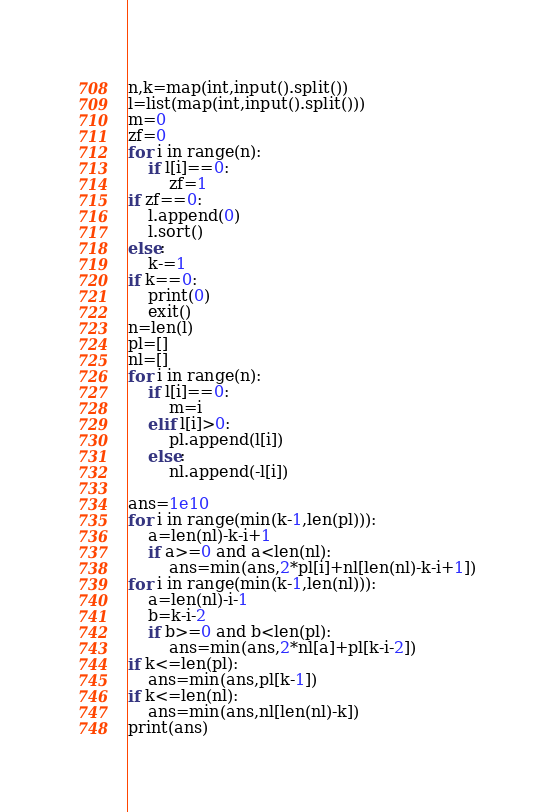<code> <loc_0><loc_0><loc_500><loc_500><_Python_>n,k=map(int,input().split())
l=list(map(int,input().split()))
m=0
zf=0
for i in range(n):
    if l[i]==0:
        zf=1
if zf==0:
    l.append(0)
    l.sort()
else:
    k-=1
if k==0:
    print(0)
    exit()
n=len(l)
pl=[]
nl=[]
for i in range(n):
    if l[i]==0:
        m=i
    elif l[i]>0:
        pl.append(l[i])
    else:
        nl.append(-l[i])
        
ans=1e10
for i in range(min(k-1,len(pl))):
    a=len(nl)-k-i+1
    if a>=0 and a<len(nl):
        ans=min(ans,2*pl[i]+nl[len(nl)-k-i+1])
for i in range(min(k-1,len(nl))):
    a=len(nl)-i-1
    b=k-i-2
    if b>=0 and b<len(pl):
        ans=min(ans,2*nl[a]+pl[k-i-2])
if k<=len(pl):
    ans=min(ans,pl[k-1])
if k<=len(nl):
    ans=min(ans,nl[len(nl)-k])
print(ans)


</code> 